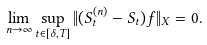Convert formula to latex. <formula><loc_0><loc_0><loc_500><loc_500>\lim _ { n \to \infty } \sup _ { t \in [ \delta , T ] } \| ( S ^ { ( n ) } _ { t } - S _ { t } ) f \| _ { X } = 0 .</formula> 